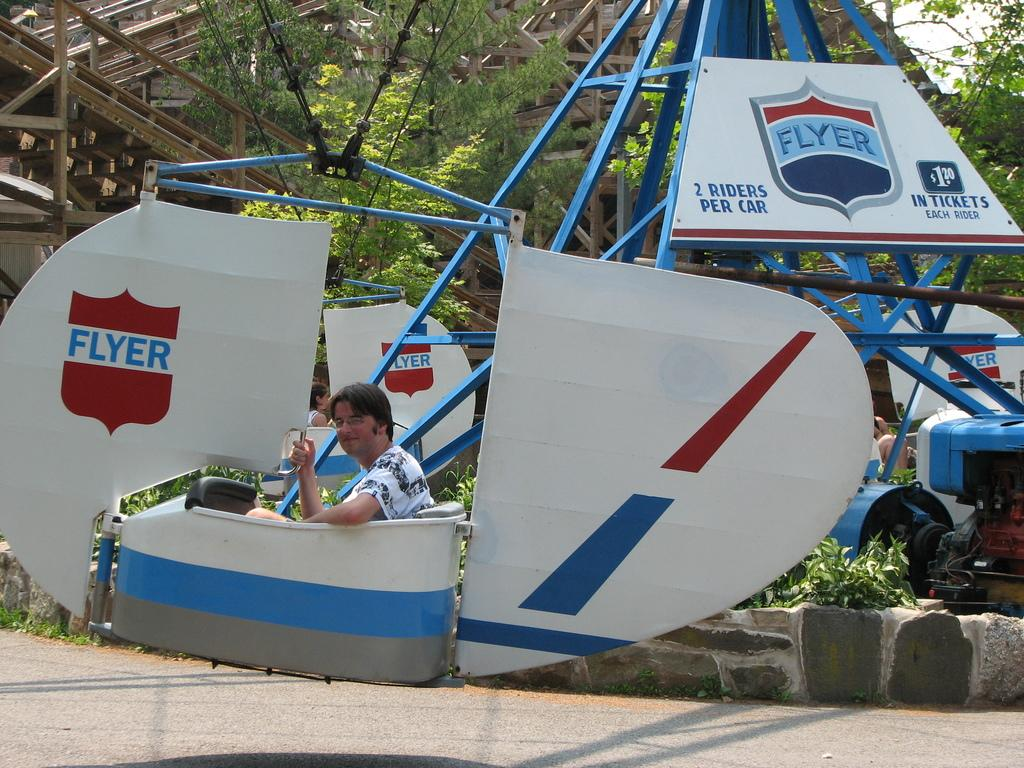<image>
Present a compact description of the photo's key features. Man on a ride with the name FLYER in the back. 